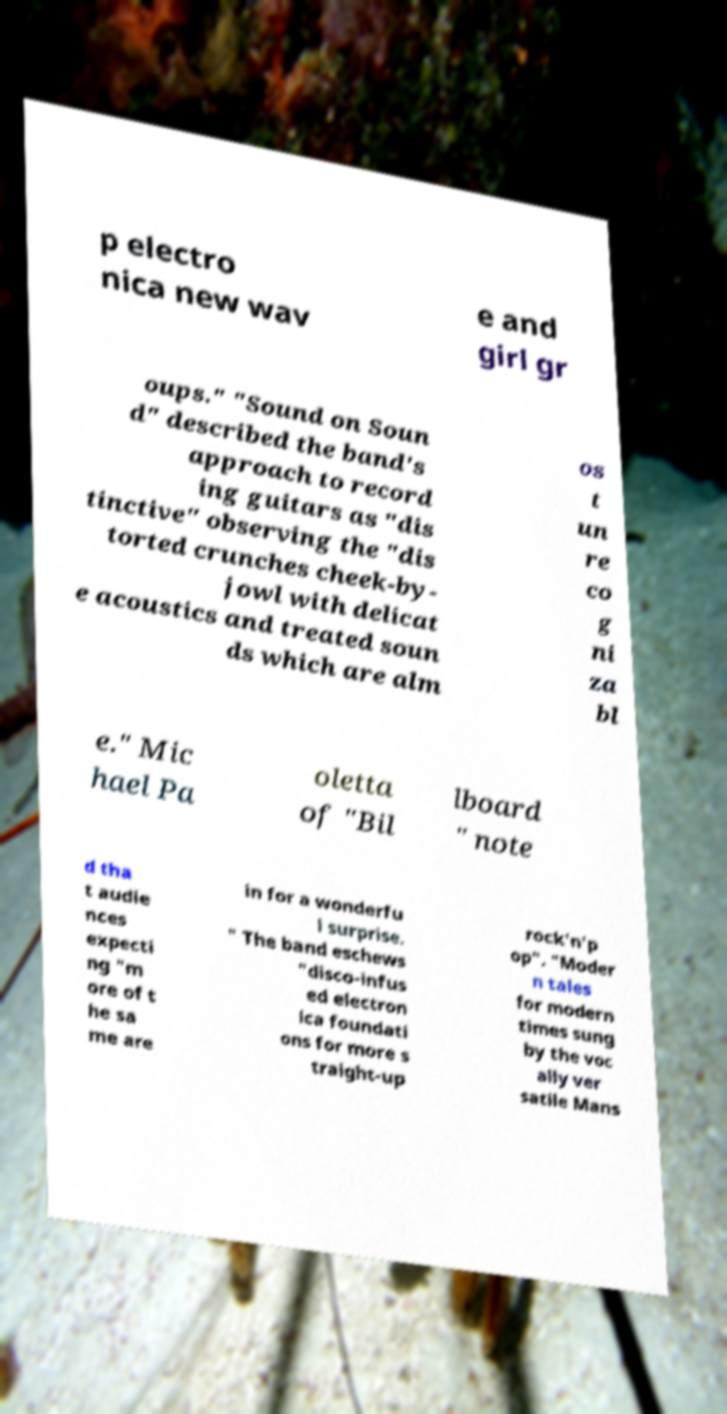Please identify and transcribe the text found in this image. p electro nica new wav e and girl gr oups." "Sound on Soun d" described the band's approach to record ing guitars as "dis tinctive" observing the "dis torted crunches cheek-by- jowl with delicat e acoustics and treated soun ds which are alm os t un re co g ni za bl e." Mic hael Pa oletta of "Bil lboard " note d tha t audie nces expecti ng "m ore of t he sa me are in for a wonderfu l surprise. " The band eschews "disco-infus ed electron ica foundati ons for more s traight-up rock'n'p op". "Moder n tales for modern times sung by the voc ally ver satile Mans 